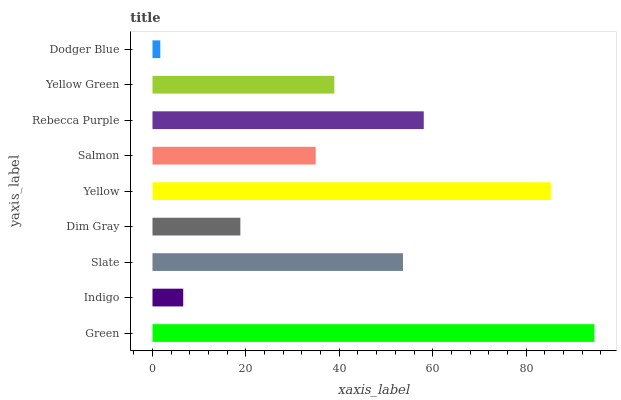Is Dodger Blue the minimum?
Answer yes or no. Yes. Is Green the maximum?
Answer yes or no. Yes. Is Indigo the minimum?
Answer yes or no. No. Is Indigo the maximum?
Answer yes or no. No. Is Green greater than Indigo?
Answer yes or no. Yes. Is Indigo less than Green?
Answer yes or no. Yes. Is Indigo greater than Green?
Answer yes or no. No. Is Green less than Indigo?
Answer yes or no. No. Is Yellow Green the high median?
Answer yes or no. Yes. Is Yellow Green the low median?
Answer yes or no. Yes. Is Yellow the high median?
Answer yes or no. No. Is Yellow the low median?
Answer yes or no. No. 